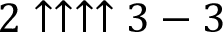<formula> <loc_0><loc_0><loc_500><loc_500>2 \uparrow \uparrow \uparrow \uparrow 3 - 3</formula> 